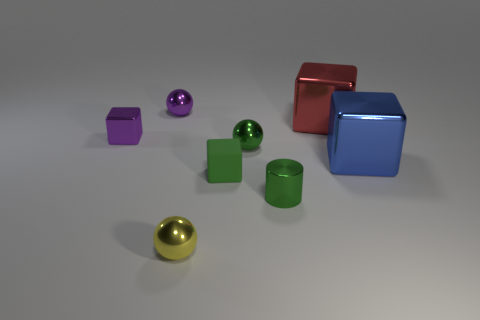Add 2 shiny balls. How many objects exist? 10 Subtract all cylinders. How many objects are left? 7 Add 5 tiny spheres. How many tiny spheres exist? 8 Subtract 0 cyan balls. How many objects are left? 8 Subtract all small shiny objects. Subtract all red metallic blocks. How many objects are left? 2 Add 1 tiny purple blocks. How many tiny purple blocks are left? 2 